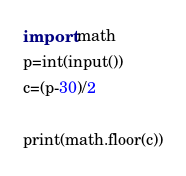Convert code to text. <code><loc_0><loc_0><loc_500><loc_500><_Python_>import math
p=int(input())
c=(p-30)/2

print(math.floor(c))
</code> 